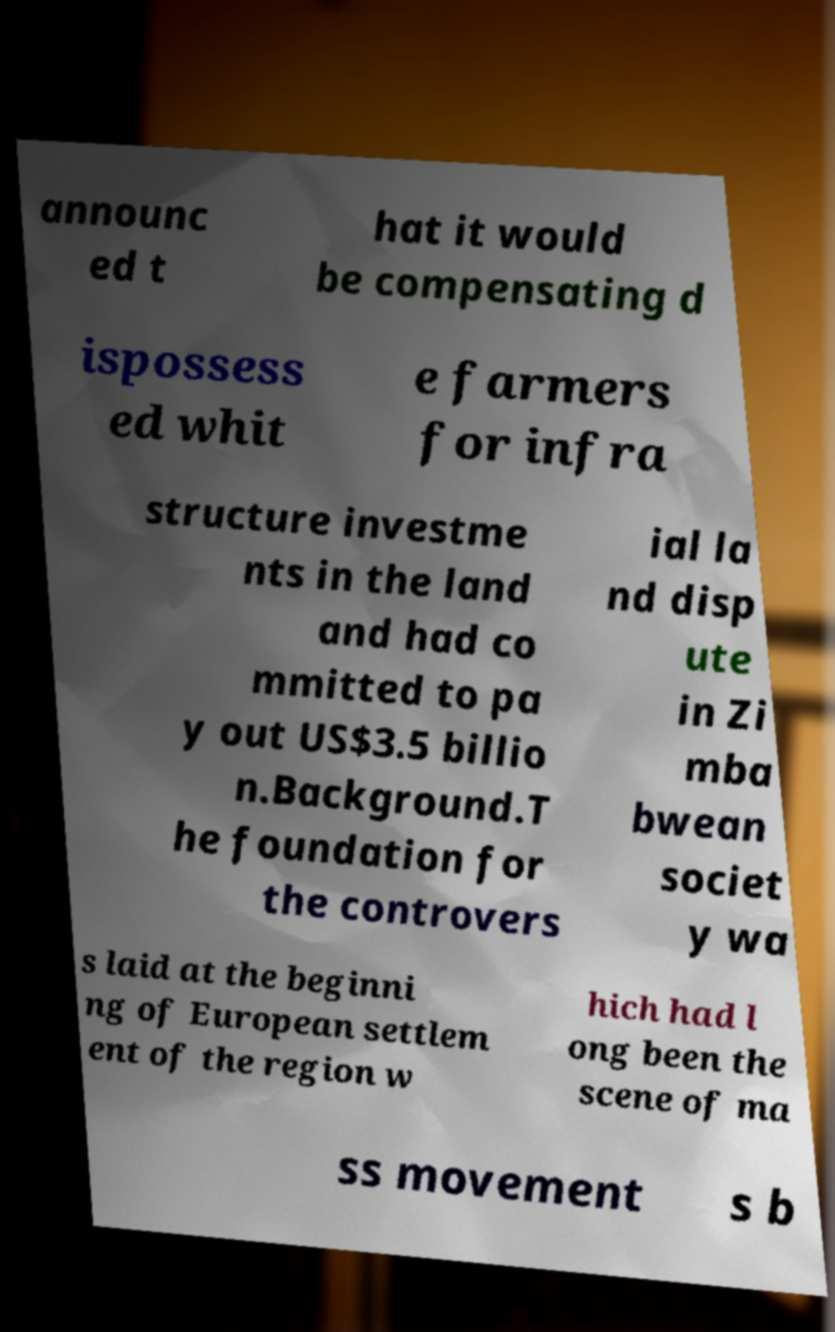Can you read and provide the text displayed in the image?This photo seems to have some interesting text. Can you extract and type it out for me? announc ed t hat it would be compensating d ispossess ed whit e farmers for infra structure investme nts in the land and had co mmitted to pa y out US$3.5 billio n.Background.T he foundation for the controvers ial la nd disp ute in Zi mba bwean societ y wa s laid at the beginni ng of European settlem ent of the region w hich had l ong been the scene of ma ss movement s b 